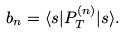<formula> <loc_0><loc_0><loc_500><loc_500>b _ { n } = \langle s | P ^ { ( n ) } _ { T } | s \rangle .</formula> 